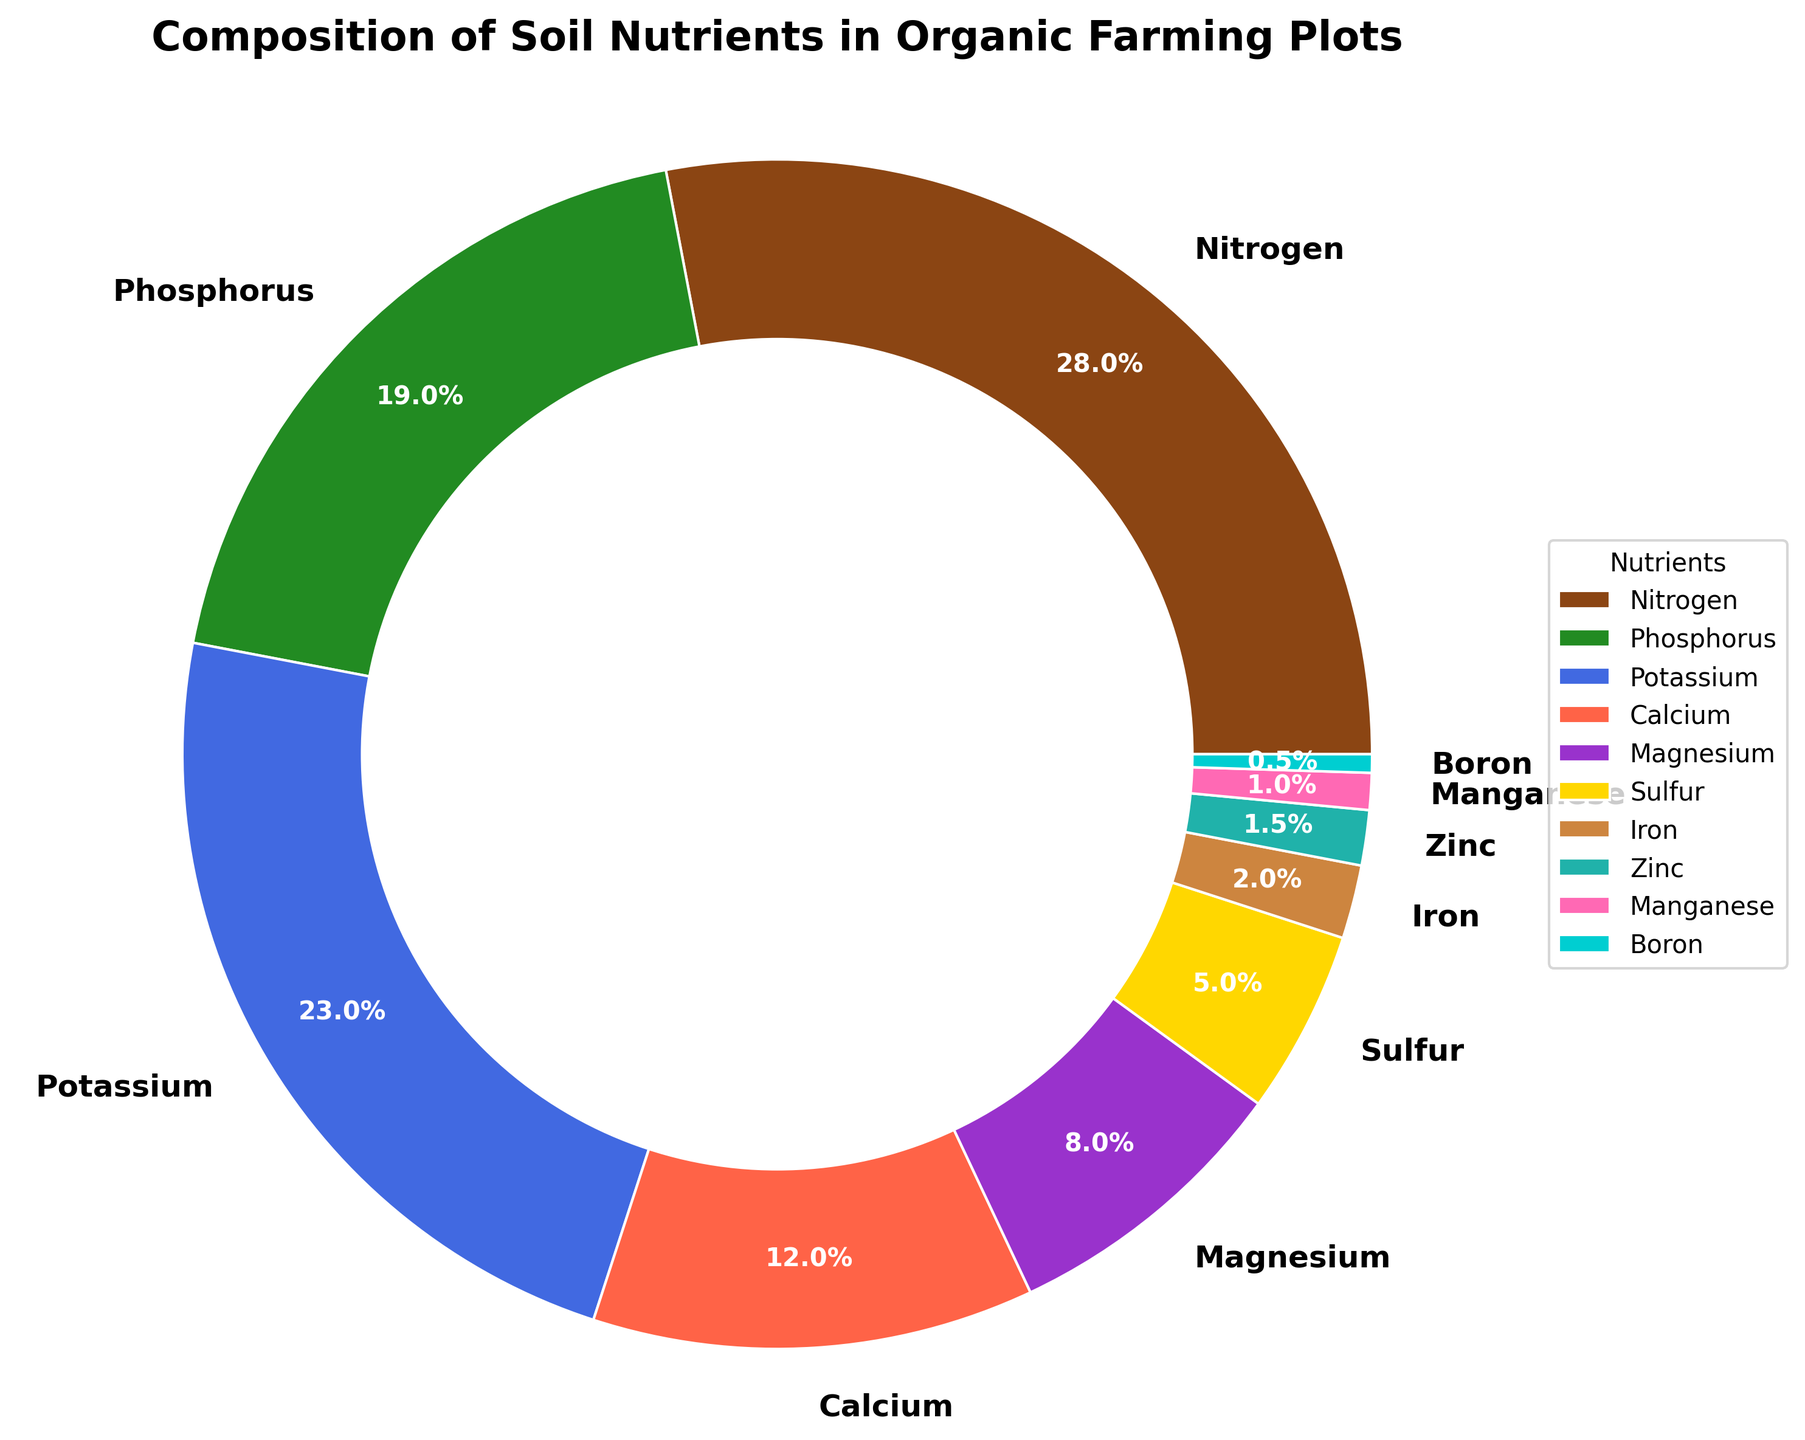What is the nutrient with the highest percentage, and what is its value? To determine the nutrient with the highest percentage, refer to the figure and identify the segment labeled with the largest value. Here, Nitrogen has the highest value.
Answer: Nitrogen, 28% Which nutrient has a higher percentage: Potassium or Phosphorus? Compare the values for Potassium and Phosphorus in the figure. Potassium has 23%, and Phosphorus has 19%.
Answer: Potassium What is the combined percentage of Calcium and Magnesium? Add the values for Calcium and Magnesium from the figure: 12% for Calcium and 8% for Magnesium, resulting in a combined percentage of 12% + 8% = 20%.
Answer: 20% Which nutrients have a percentage lower than 5%, and what are their exact values? Identify the segments in the pie chart with values lower than 5%. These are Sulfur (5% does not count as lower), Iron, Zinc, Manganese, and Boron with the respective values from the figure.
Answer: Iron: 2%, Zinc: 1.5%, Manganese: 1%, Boron: 0.5% What is the total percentage of the primary macronutrients (Nitrogen, Phosphorus, Potassium)? Sum the percentages of Nitrogen, Phosphorus, and Potassium: 28% + 19% + 23% = 70%.
Answer: 70% Which segment of the pie is colored green, and what nutrient does it represent? Look for the green segment in the pie chart. The green color represents Phosphorus.
Answer: Phosphorus Compare the percentages of Sulfur and Iron. Which one is greater, and by how much? Subtract the percentage of Iron from Sulfur: 5% - 2% = 3%. Sulfur is greater than Iron by 3%.
Answer: Sulfur by 3% How many nutrients have a percentage greater than or equal to 10%? Count the segments in the figure where the values are 10% or more: Nitrogen, Phosphorus, Potassium, and Calcium. There are four such nutrients.
Answer: 4 What fraction of the soil's nutrient composition is made up of trace elements (Iron, Zinc, Manganese, Boron)? Add the percentages of Iron, Zinc, Manganese, and Boron: 2% + 1.5% + 1% + 0.5% = 5%. This means trace elements make up 5/100 or 1/20th of the soil composition.
Answer: 1/20 What percentage is represented by all nutrients except Nitrogen? To find this, subtract Nitrogen's percentage from 100%: 100% - 28% = 72%.
Answer: 72% 